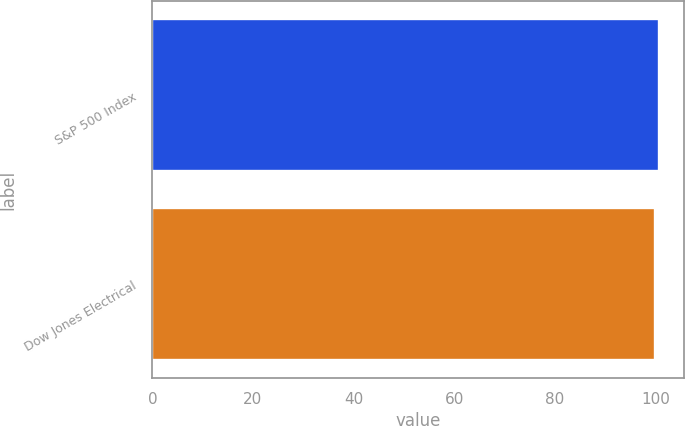<chart> <loc_0><loc_0><loc_500><loc_500><bar_chart><fcel>S&P 500 Index<fcel>Dow Jones Electrical<nl><fcel>100.77<fcel>99.97<nl></chart> 